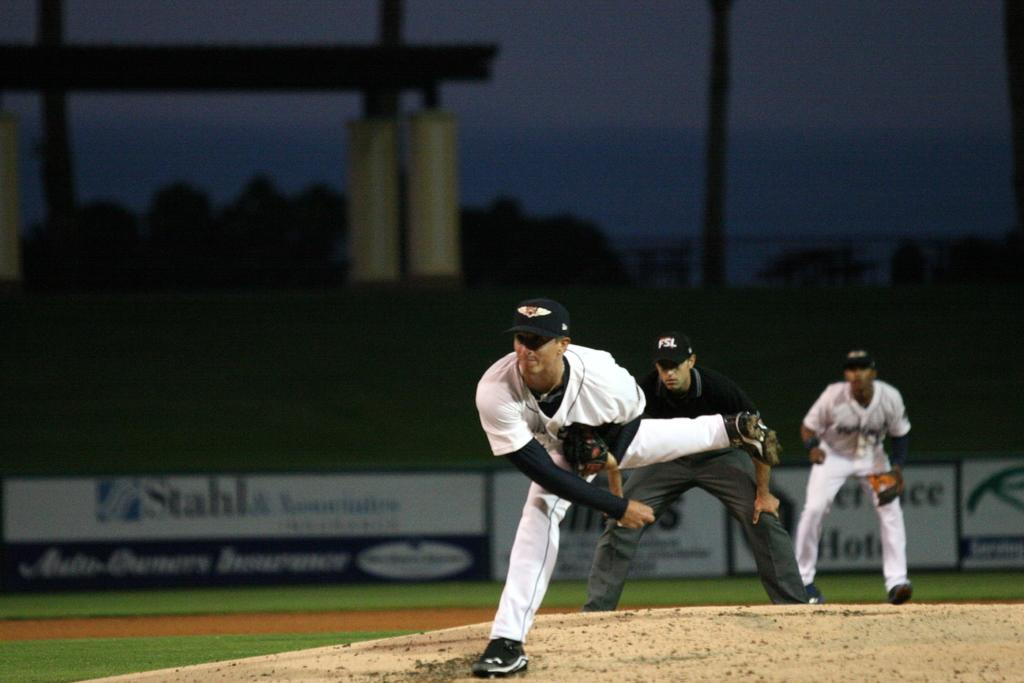<image>
Create a compact narrative representing the image presented. A baseball game is being played at a stadium with an advertisement for Stahl displayed. 